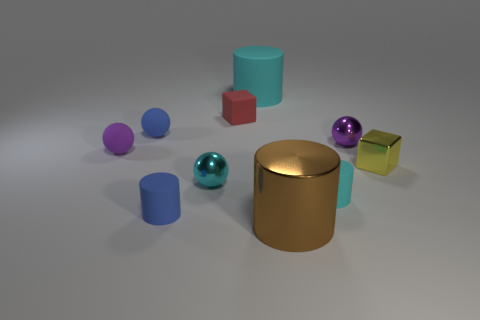The purple rubber ball is what size?
Keep it short and to the point. Small. The shiny thing that is behind the small purple object on the left side of the cyan matte thing that is in front of the purple rubber sphere is what color?
Your answer should be compact. Purple. Does the tiny cylinder on the right side of the brown cylinder have the same color as the large matte thing?
Offer a terse response. Yes. What number of tiny objects are to the left of the yellow block and behind the cyan metal sphere?
Your answer should be compact. 4. What is the size of the other matte object that is the same shape as the yellow thing?
Offer a very short reply. Small. What number of brown objects are right of the object in front of the tiny blue matte thing that is in front of the metallic block?
Keep it short and to the point. 0. What is the color of the cube that is behind the small rubber sphere behind the purple rubber ball?
Your answer should be compact. Red. What number of other objects are there of the same material as the cyan ball?
Offer a terse response. 3. There is a tiny cyan thing left of the red rubber thing; how many large brown metal cylinders are in front of it?
Offer a very short reply. 1. Are there any other things that are the same shape as the small yellow thing?
Keep it short and to the point. Yes. 